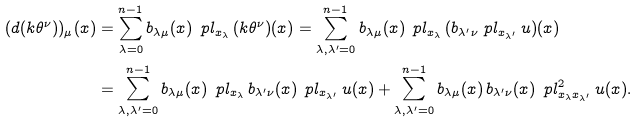<formula> <loc_0><loc_0><loc_500><loc_500>( d ( k \theta ^ { \nu } ) ) _ { \mu } ( x ) & = \sum _ { \lambda = 0 } ^ { n - 1 } b _ { \lambda \mu } ( x ) \, \ p l _ { x _ { \lambda } } \, ( k \theta ^ { \nu } ) ( x ) = \sum _ { \lambda , \lambda ^ { \prime } = 0 } ^ { n - 1 } b _ { \lambda \mu } ( x ) \, \ p l _ { x _ { \lambda } } \, ( b _ { \lambda ^ { \prime } \nu } \ p l _ { x _ { \lambda ^ { \prime } } } \, u ) ( x ) \\ & = \sum _ { \lambda , \lambda ^ { \prime } = 0 } ^ { n - 1 } b _ { \lambda \mu } ( x ) \, \ p l _ { x _ { \lambda } } \, b _ { \lambda ^ { \prime } \nu } ( x ) \, \ p l _ { x _ { \lambda ^ { \prime } } } \, u ( x ) + \sum _ { \lambda , \lambda ^ { \prime } = 0 } ^ { n - 1 } b _ { \lambda \mu } ( x ) \, b _ { \lambda ^ { \prime } \nu } ( x ) \, \ p l ^ { 2 } _ { x _ { \lambda } x _ { \lambda ^ { \prime } } } \, u ( x ) .</formula> 